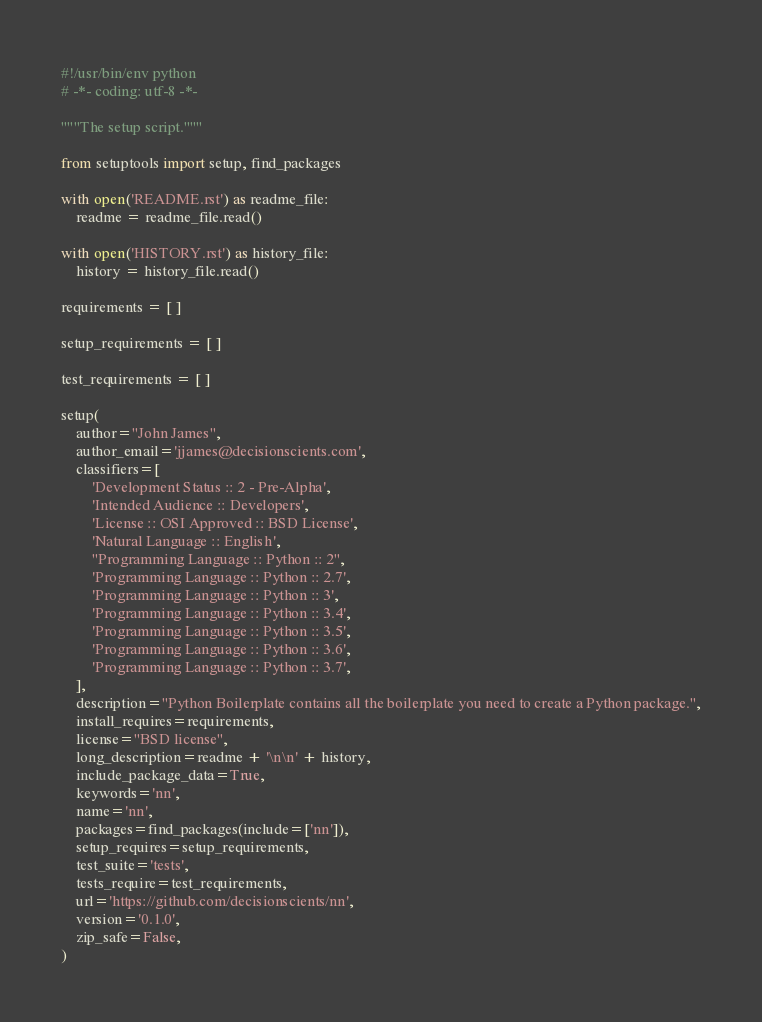Convert code to text. <code><loc_0><loc_0><loc_500><loc_500><_Python_>#!/usr/bin/env python
# -*- coding: utf-8 -*-

"""The setup script."""

from setuptools import setup, find_packages

with open('README.rst') as readme_file:
    readme = readme_file.read()

with open('HISTORY.rst') as history_file:
    history = history_file.read()

requirements = [ ]

setup_requirements = [ ]

test_requirements = [ ]

setup(
    author="John James",
    author_email='jjames@decisionscients.com',
    classifiers=[
        'Development Status :: 2 - Pre-Alpha',
        'Intended Audience :: Developers',
        'License :: OSI Approved :: BSD License',
        'Natural Language :: English',
        "Programming Language :: Python :: 2",
        'Programming Language :: Python :: 2.7',
        'Programming Language :: Python :: 3',
        'Programming Language :: Python :: 3.4',
        'Programming Language :: Python :: 3.5',
        'Programming Language :: Python :: 3.6',
        'Programming Language :: Python :: 3.7',
    ],
    description="Python Boilerplate contains all the boilerplate you need to create a Python package.",
    install_requires=requirements,
    license="BSD license",
    long_description=readme + '\n\n' + history,
    include_package_data=True,
    keywords='nn',
    name='nn',
    packages=find_packages(include=['nn']),
    setup_requires=setup_requirements,
    test_suite='tests',
    tests_require=test_requirements,
    url='https://github.com/decisionscients/nn',
    version='0.1.0',
    zip_safe=False,
)
</code> 